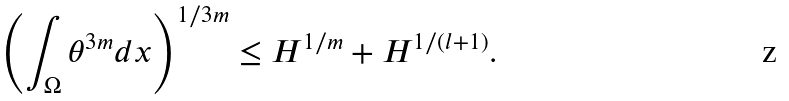Convert formula to latex. <formula><loc_0><loc_0><loc_500><loc_500>\left ( \int _ { \Omega } \theta ^ { 3 m } d x \right ) ^ { 1 / 3 m } \leq H ^ { 1 / m } + H ^ { 1 / ( l + 1 ) } .</formula> 